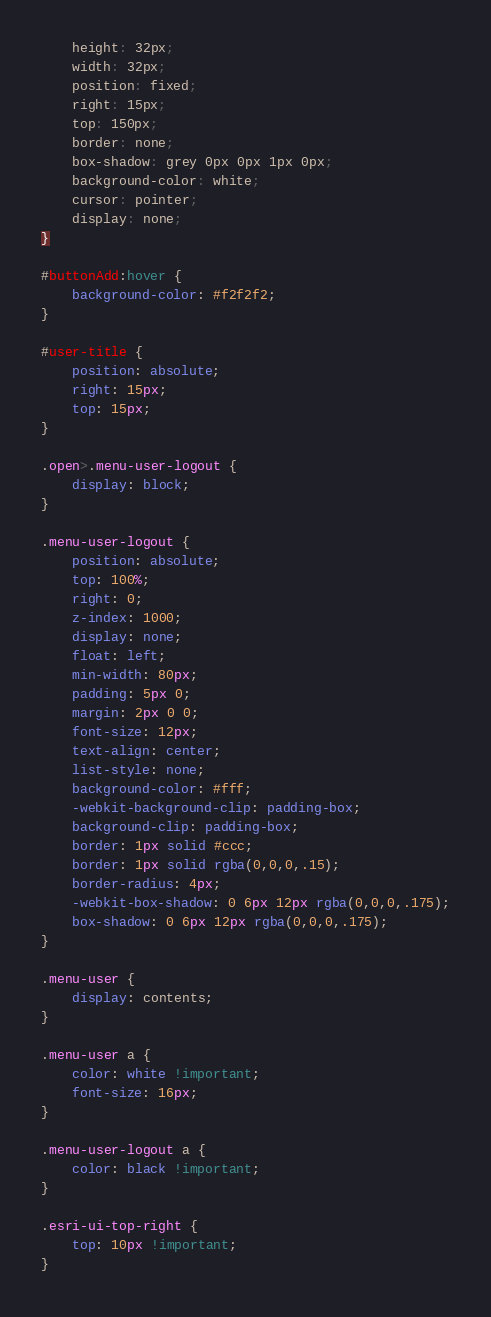Convert code to text. <code><loc_0><loc_0><loc_500><loc_500><_CSS_>    height: 32px;
    width: 32px;
    position: fixed;
    right: 15px;
    top: 150px;
    border: none;
    box-shadow: grey 0px 0px 1px 0px;
    background-color: white;
    cursor: pointer;
    display: none;
}

#buttonAdd:hover {
    background-color: #f2f2f2;
}

#user-title {
    position: absolute;
    right: 15px;
    top: 15px;
}

.open>.menu-user-logout {
    display: block;
}

.menu-user-logout {
    position: absolute;
    top: 100%;
    right: 0;
    z-index: 1000;
    display: none;
    float: left;
    min-width: 80px;
    padding: 5px 0;
    margin: 2px 0 0;
    font-size: 12px;
    text-align: center;
    list-style: none;
    background-color: #fff;
    -webkit-background-clip: padding-box;
    background-clip: padding-box;
    border: 1px solid #ccc;
    border: 1px solid rgba(0,0,0,.15);
    border-radius: 4px;
    -webkit-box-shadow: 0 6px 12px rgba(0,0,0,.175);
    box-shadow: 0 6px 12px rgba(0,0,0,.175);
}

.menu-user {
    display: contents;
}

.menu-user a {
    color: white !important;
    font-size: 16px;
}

.menu-user-logout a {
    color: black !important;
}

.esri-ui-top-right {
    top: 10px !important;
}

</code> 